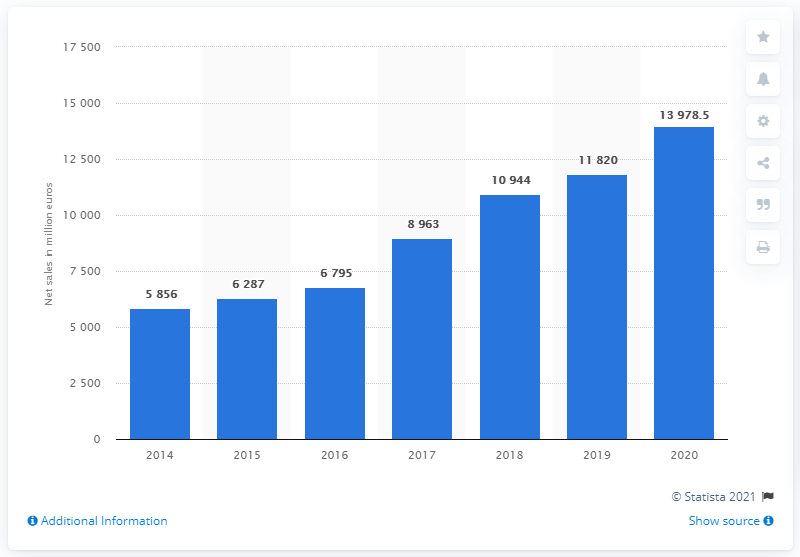Outline some significant characteristics in this image. ASML's net sales revenue in 2020 was 13,978.5. 